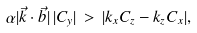Convert formula to latex. <formula><loc_0><loc_0><loc_500><loc_500>\alpha | \vec { k } \cdot \vec { b } | \, | C _ { y } | \, > \, | k _ { x } C _ { z } - k _ { z } C _ { x } | ,</formula> 